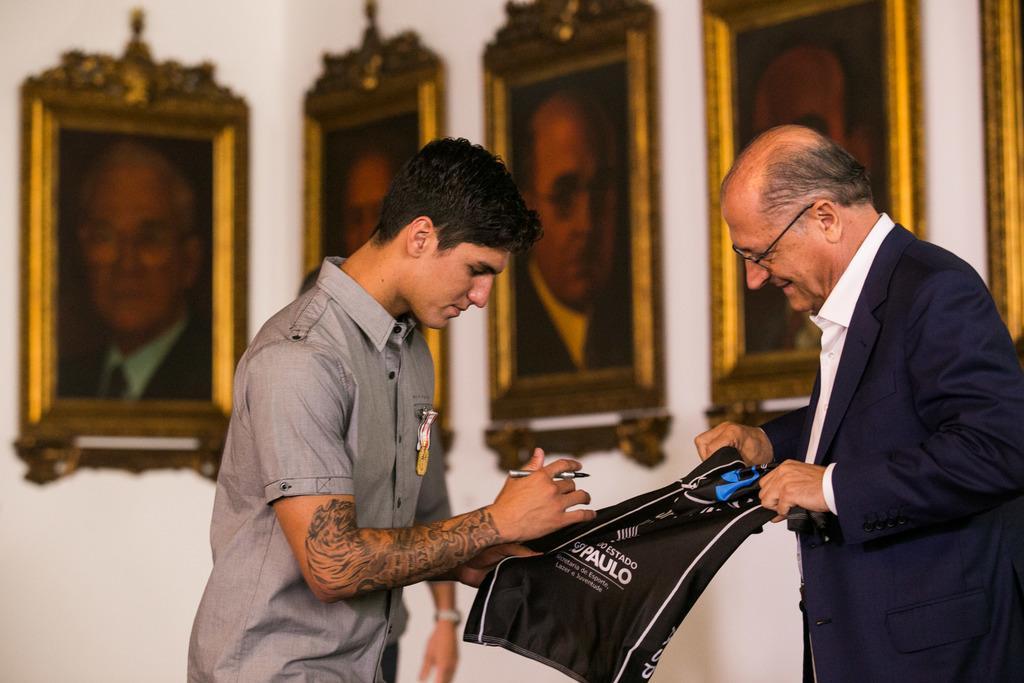Please provide a concise description of this image. In the picture we can see an old man with a blue color blazer and white shirt standing and holding some cloth which is black in color and something written on it and a boy is also holding a same cloth in his hand and hold a pen in the other hand and he is wearing a shirt and to his hand we can see a tattoo, and in the background we can see a wall with some photo frames and photos of humans in it. 